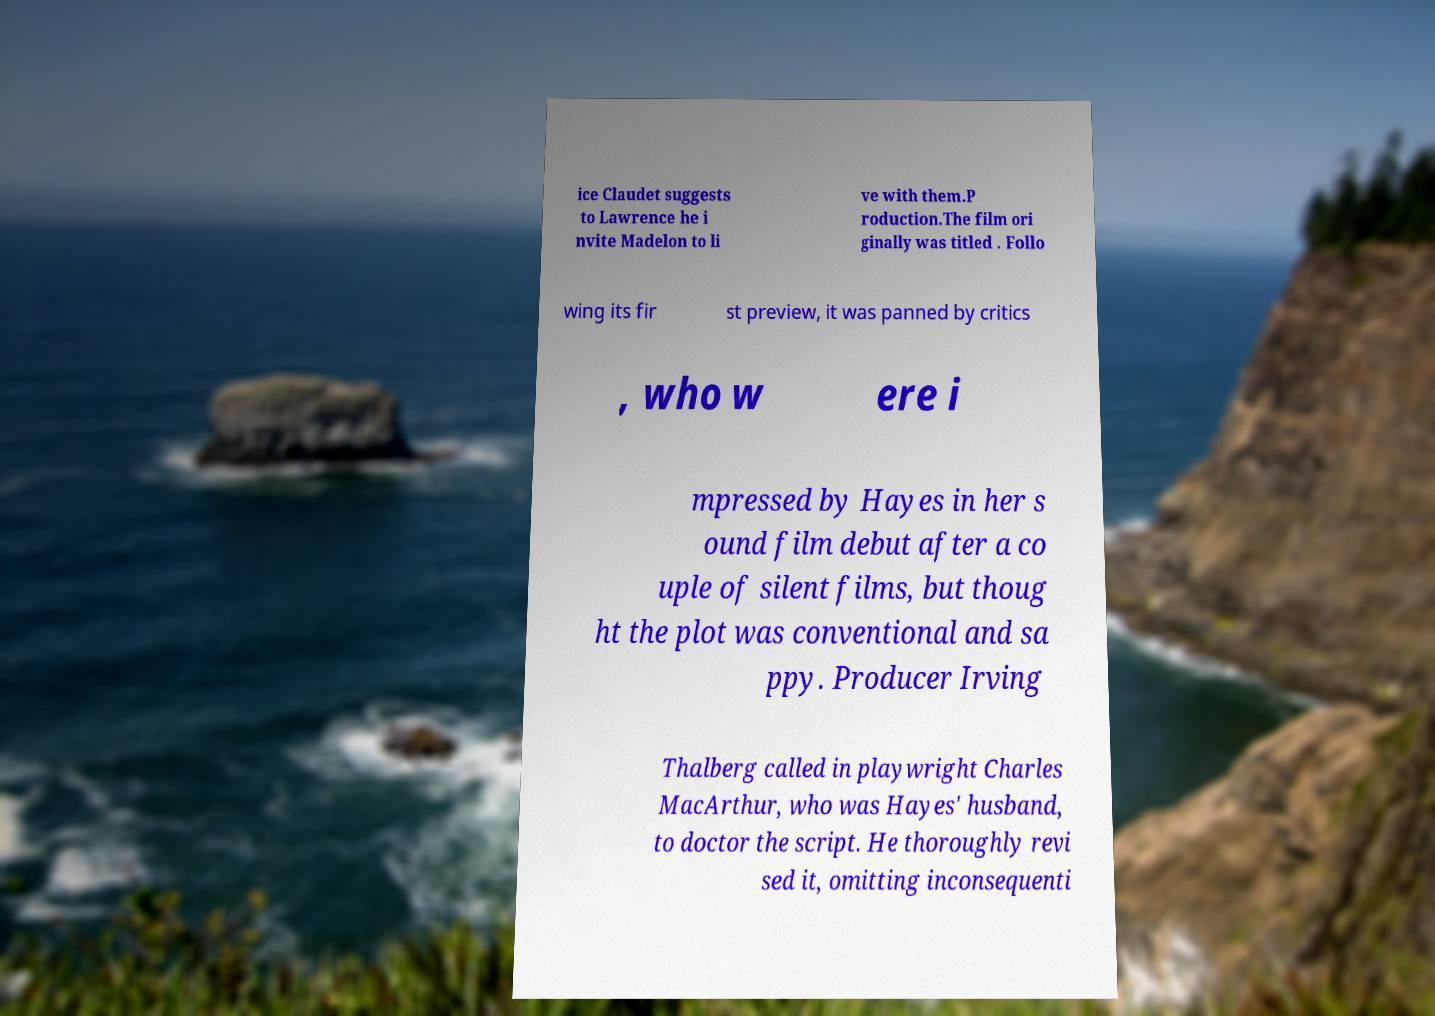For documentation purposes, I need the text within this image transcribed. Could you provide that? ice Claudet suggests to Lawrence he i nvite Madelon to li ve with them.P roduction.The film ori ginally was titled . Follo wing its fir st preview, it was panned by critics , who w ere i mpressed by Hayes in her s ound film debut after a co uple of silent films, but thoug ht the plot was conventional and sa ppy. Producer Irving Thalberg called in playwright Charles MacArthur, who was Hayes' husband, to doctor the script. He thoroughly revi sed it, omitting inconsequenti 